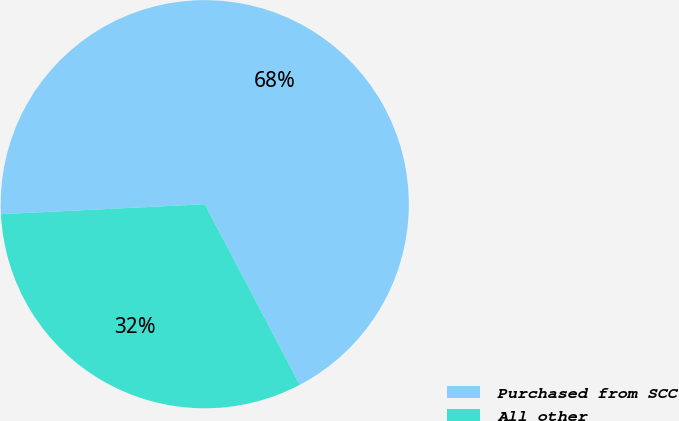Convert chart to OTSL. <chart><loc_0><loc_0><loc_500><loc_500><pie_chart><fcel>Purchased from SCC<fcel>All other<nl><fcel>68.07%<fcel>31.93%<nl></chart> 